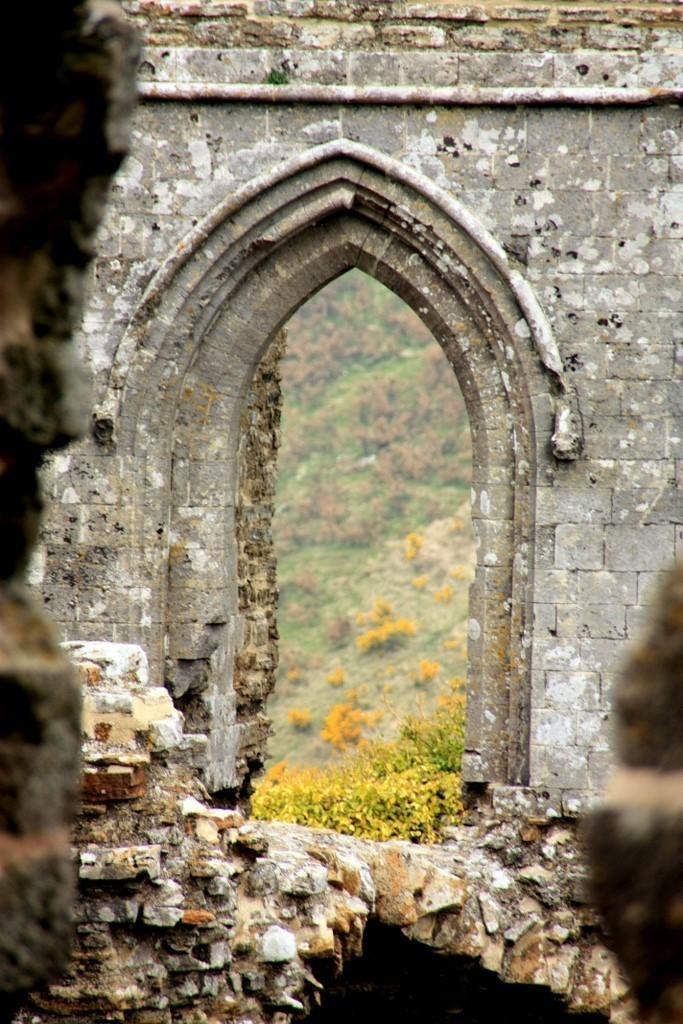How would you summarize this image in a sentence or two? In this picture we can see the monument. In the background we can see the mountain, plants and grass. 